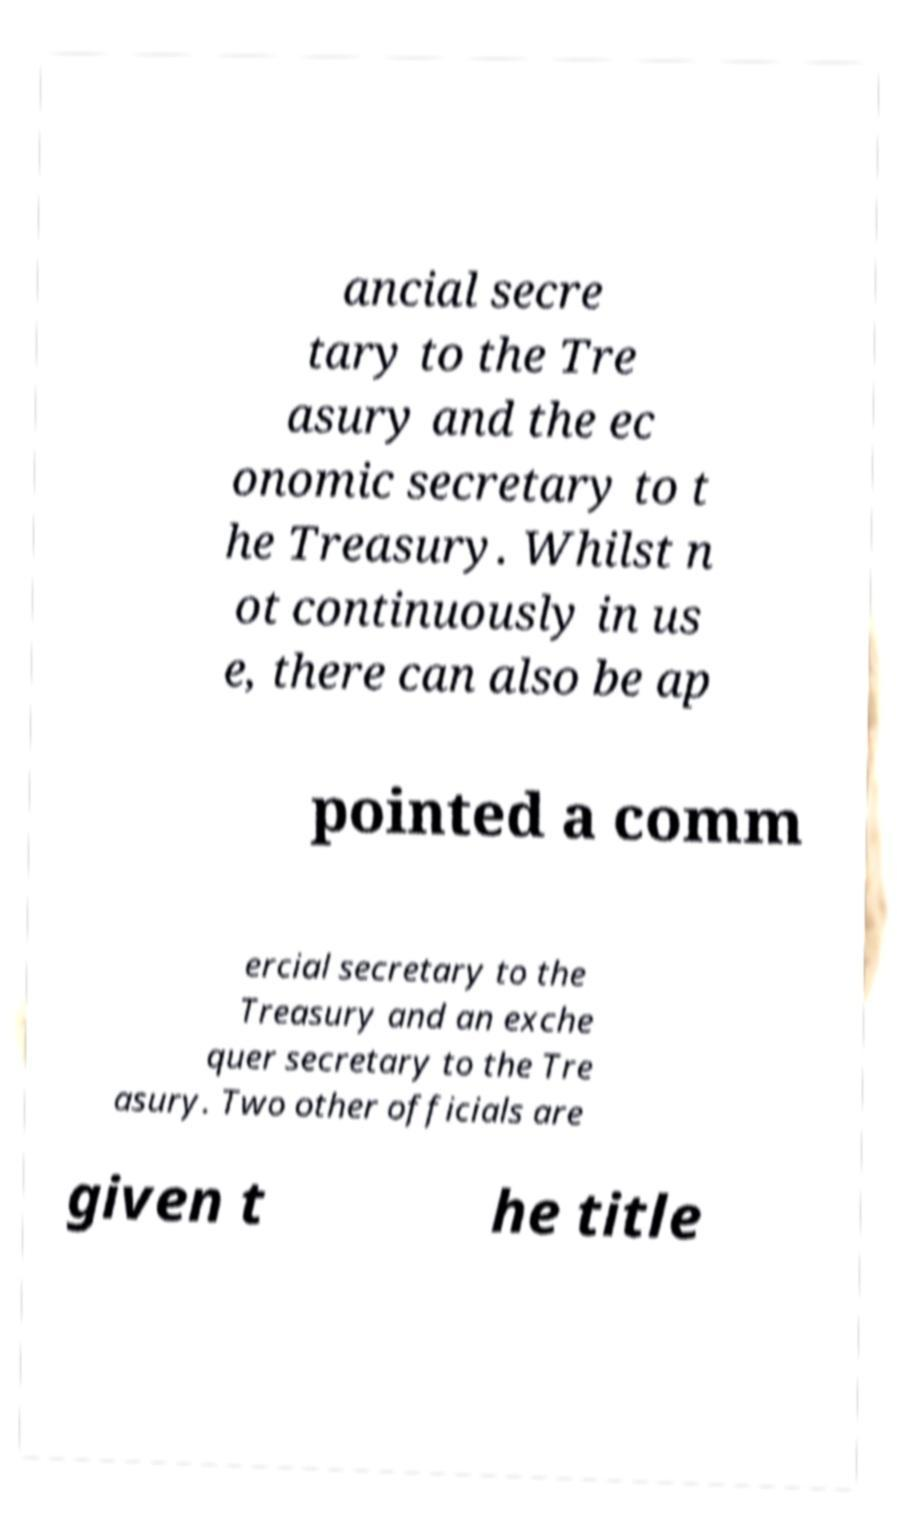Can you read and provide the text displayed in the image?This photo seems to have some interesting text. Can you extract and type it out for me? ancial secre tary to the Tre asury and the ec onomic secretary to t he Treasury. Whilst n ot continuously in us e, there can also be ap pointed a comm ercial secretary to the Treasury and an exche quer secretary to the Tre asury. Two other officials are given t he title 